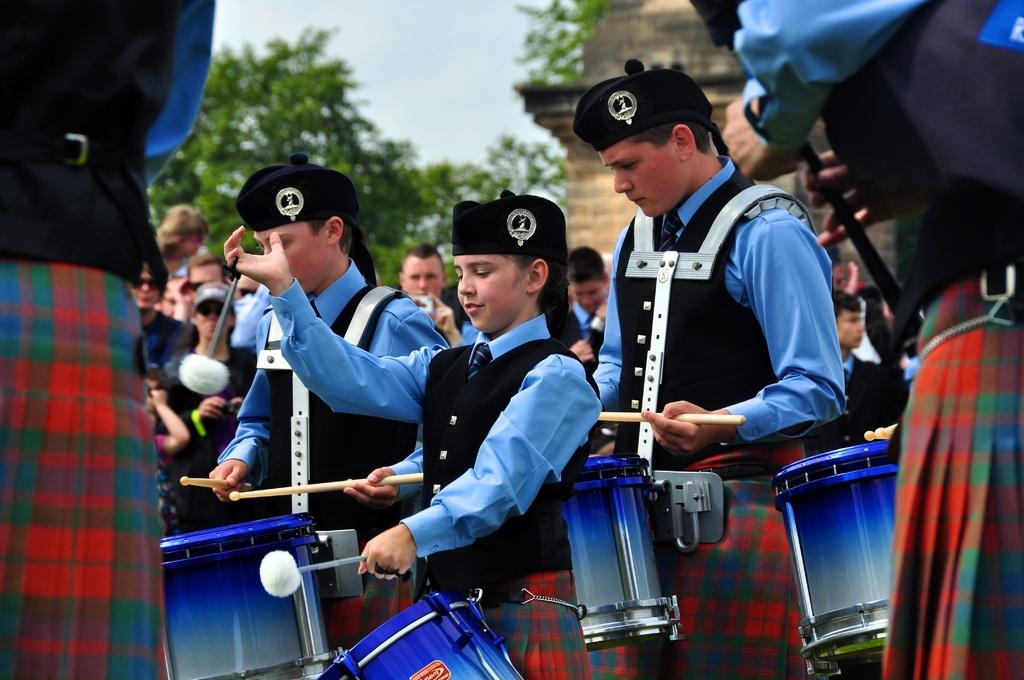What are the people wearing in the image? The people are wearing caps in the image. What activity are the people engaged in? These people are playing drums. Can you describe the background of the image? There are many people and trees in the background of the image, and the sky is also visible. What type of stamp can be seen on the drum in the image? There is no stamp visible on the drum in the image. What color is the polish on the people's nails in the image? There is no mention of nail polish or people's nails in the image. 